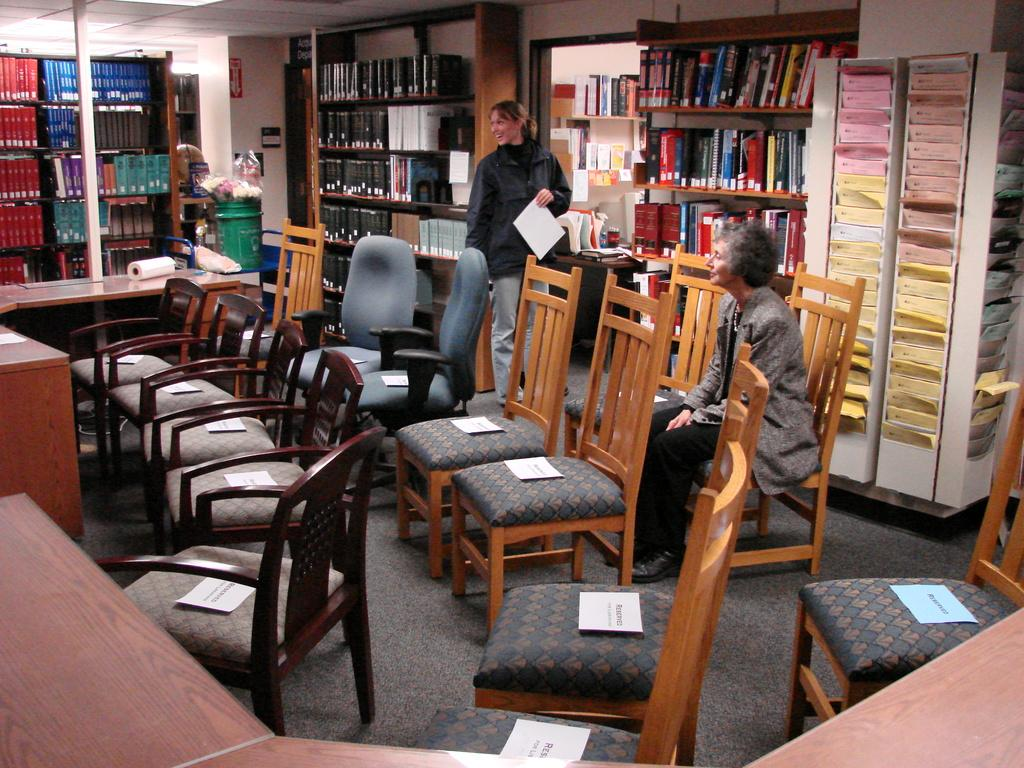How many women are in the image? There are two women in the image. What is one of the women doing in the image? One of the women is sitting on a chair. How many chairs are visible in the image? There are multiple chairs in the image. What other furniture can be seen in the image? There are tables in the image. What type of storage is present on the floor in the image? There are shelves on the floor in the image. What type of bottle is visible on the hill in the image? There is no bottle or hill present in the image. What color is the skirt worn by the woman in the image? The provided facts do not mention the color or presence of a skirt on either woman in the image. 